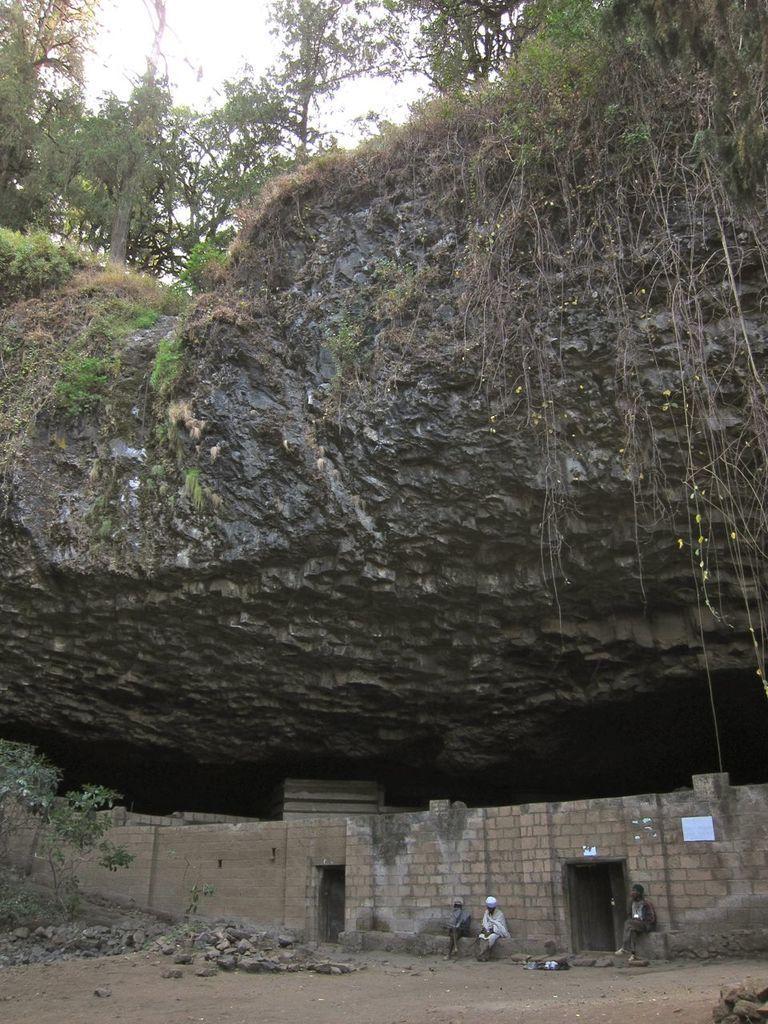Please provide a concise description of this image. In this picture there is a huge rock and there are few trees above it and there is a brick wall and three persons under the rock. 